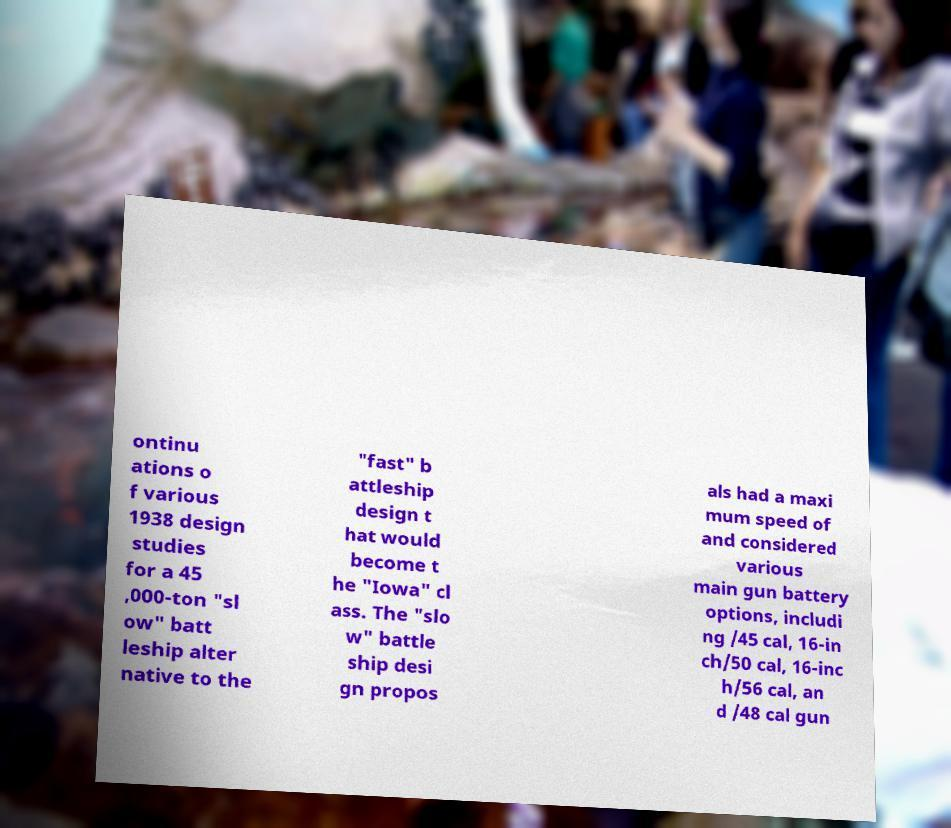Could you extract and type out the text from this image? ontinu ations o f various 1938 design studies for a 45 ,000-ton "sl ow" batt leship alter native to the "fast" b attleship design t hat would become t he "Iowa" cl ass. The "slo w" battle ship desi gn propos als had a maxi mum speed of and considered various main gun battery options, includi ng /45 cal, 16-in ch/50 cal, 16-inc h/56 cal, an d /48 cal gun 